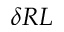Convert formula to latex. <formula><loc_0><loc_0><loc_500><loc_500>\delta R L</formula> 